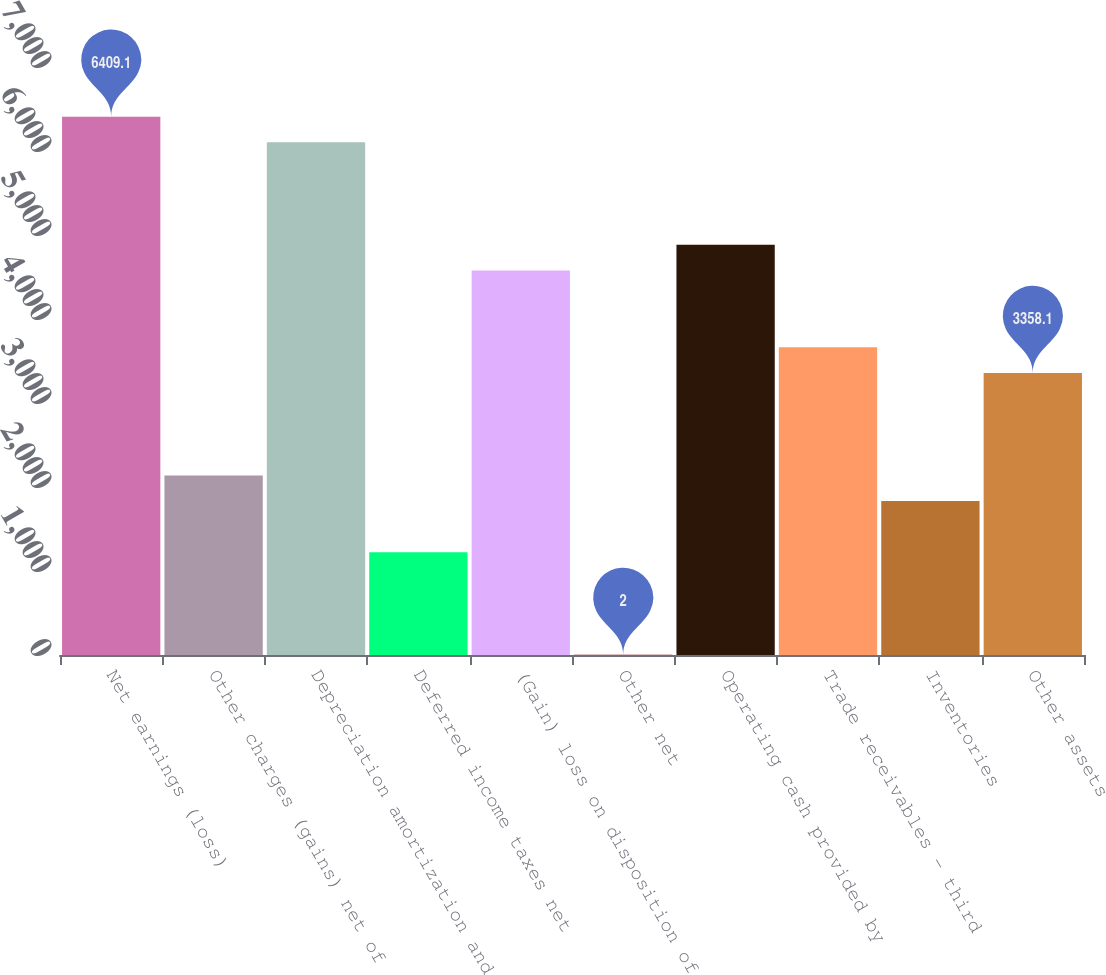Convert chart. <chart><loc_0><loc_0><loc_500><loc_500><bar_chart><fcel>Net earnings (loss)<fcel>Other charges (gains) net of<fcel>Depreciation amortization and<fcel>Deferred income taxes net<fcel>(Gain) loss on disposition of<fcel>Other net<fcel>Operating cash provided by<fcel>Trade receivables - third<fcel>Inventories<fcel>Other assets<nl><fcel>6409.1<fcel>2137.7<fcel>6104<fcel>1222.4<fcel>4578.5<fcel>2<fcel>4883.6<fcel>3663.2<fcel>1832.6<fcel>3358.1<nl></chart> 